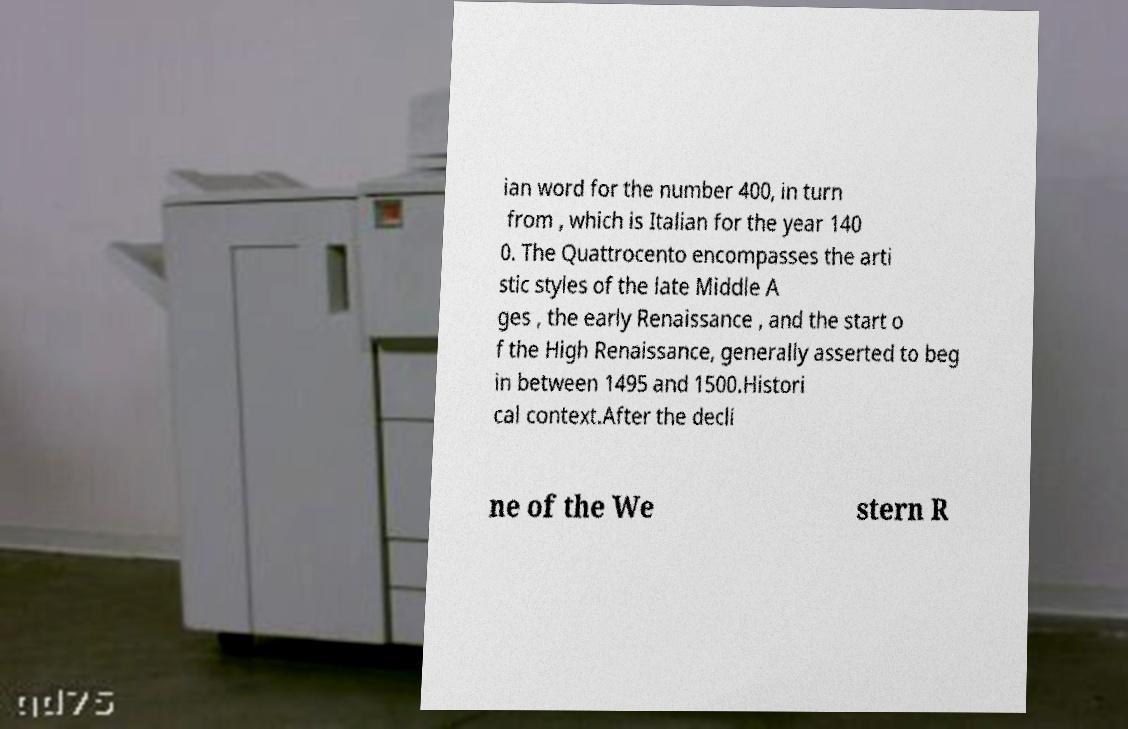There's text embedded in this image that I need extracted. Can you transcribe it verbatim? ian word for the number 400, in turn from , which is Italian for the year 140 0. The Quattrocento encompasses the arti stic styles of the late Middle A ges , the early Renaissance , and the start o f the High Renaissance, generally asserted to beg in between 1495 and 1500.Histori cal context.After the decli ne of the We stern R 